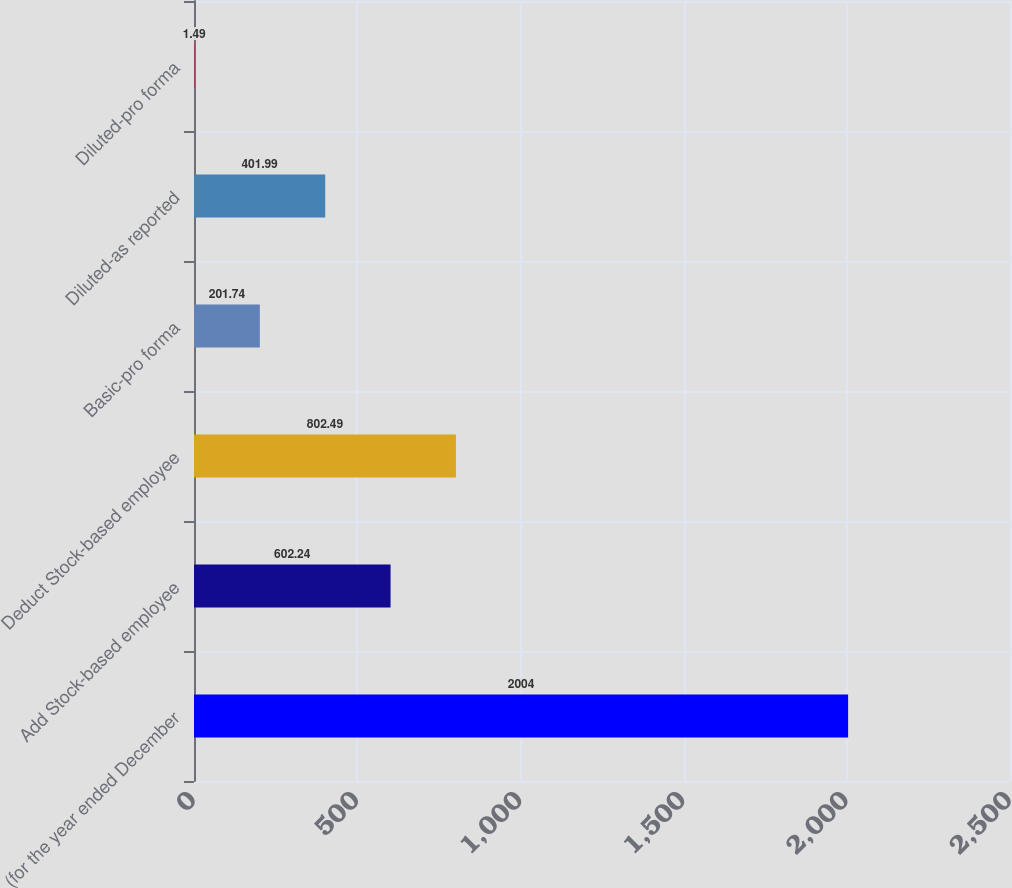Convert chart. <chart><loc_0><loc_0><loc_500><loc_500><bar_chart><fcel>(for the year ended December<fcel>Add Stock-based employee<fcel>Deduct Stock-based employee<fcel>Basic-pro forma<fcel>Diluted-as reported<fcel>Diluted-pro forma<nl><fcel>2004<fcel>602.24<fcel>802.49<fcel>201.74<fcel>401.99<fcel>1.49<nl></chart> 